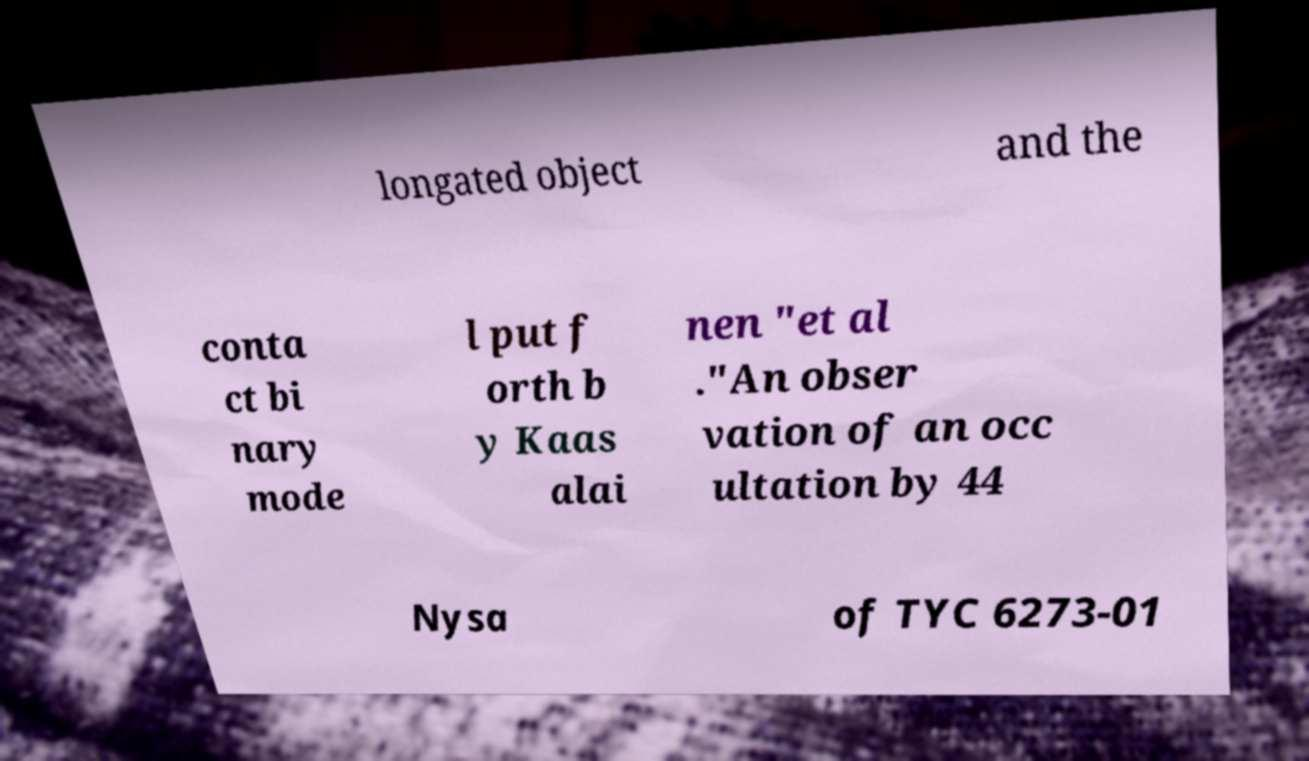Could you assist in decoding the text presented in this image and type it out clearly? longated object and the conta ct bi nary mode l put f orth b y Kaas alai nen "et al ."An obser vation of an occ ultation by 44 Nysa of TYC 6273-01 